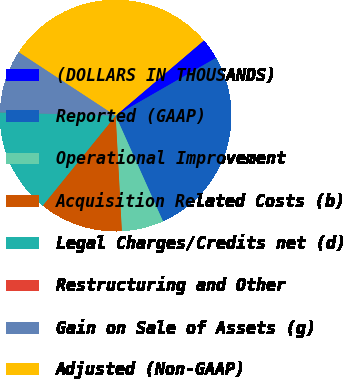Convert chart. <chart><loc_0><loc_0><loc_500><loc_500><pie_chart><fcel>(DOLLARS IN THOUSANDS)<fcel>Reported (GAAP)<fcel>Operational Improvement<fcel>Acquisition Related Costs (b)<fcel>Legal Charges/Credits net (d)<fcel>Restructuring and Other<fcel>Gain on Sale of Assets (g)<fcel>Adjusted (Non-GAAP)<nl><fcel>2.93%<fcel>26.6%<fcel>5.85%<fcel>11.69%<fcel>14.61%<fcel>0.02%<fcel>8.77%<fcel>29.52%<nl></chart> 